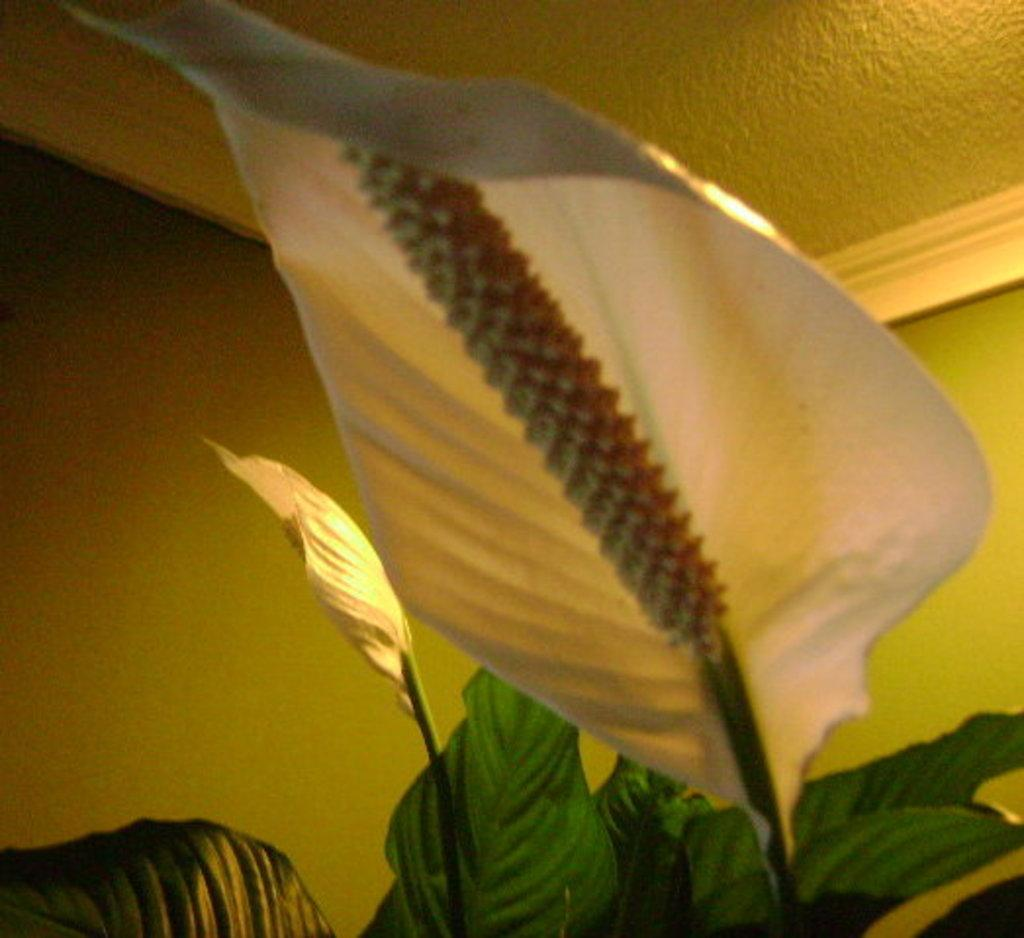What is the main subject in the middle of the image? There is a leaf in the middle of the image. What else can be seen related to plants in the image? There is a plant with leaves at the bottom of the image. What type of structures can be seen in the background of the image? There is a wall and a roof in the background of the image. What can be seen providing light in the background of the image? There is a light source in the background of the image. What type of joke is the mother telling in the image? There is no mother or joke present in the image; it features a leaf and a plant with leaves, along with a wall, roof, and light source in the background. 